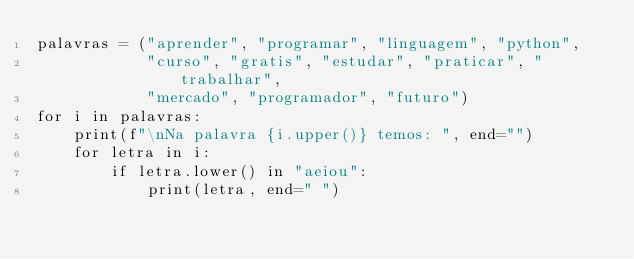Convert code to text. <code><loc_0><loc_0><loc_500><loc_500><_Python_>palavras = ("aprender", "programar", "linguagem", "python",
            "curso", "gratis", "estudar", "praticar", "trabalhar",
            "mercado", "programador", "futuro")
for i in palavras:
    print(f"\nNa palavra {i.upper()} temos: ", end="")
    for letra in i:
        if letra.lower() in "aeiou":
            print(letra, end=" ")
</code> 